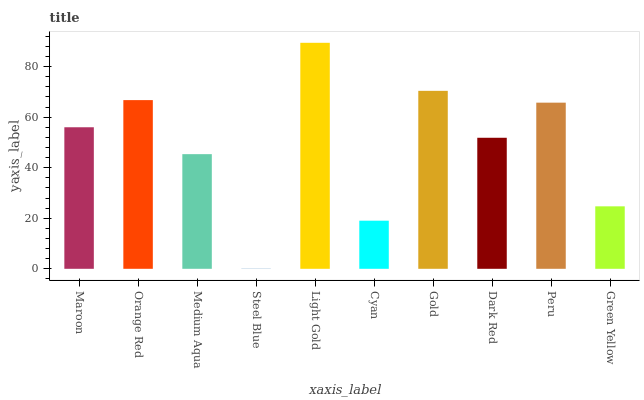Is Steel Blue the minimum?
Answer yes or no. Yes. Is Light Gold the maximum?
Answer yes or no. Yes. Is Orange Red the minimum?
Answer yes or no. No. Is Orange Red the maximum?
Answer yes or no. No. Is Orange Red greater than Maroon?
Answer yes or no. Yes. Is Maroon less than Orange Red?
Answer yes or no. Yes. Is Maroon greater than Orange Red?
Answer yes or no. No. Is Orange Red less than Maroon?
Answer yes or no. No. Is Maroon the high median?
Answer yes or no. Yes. Is Dark Red the low median?
Answer yes or no. Yes. Is Green Yellow the high median?
Answer yes or no. No. Is Cyan the low median?
Answer yes or no. No. 